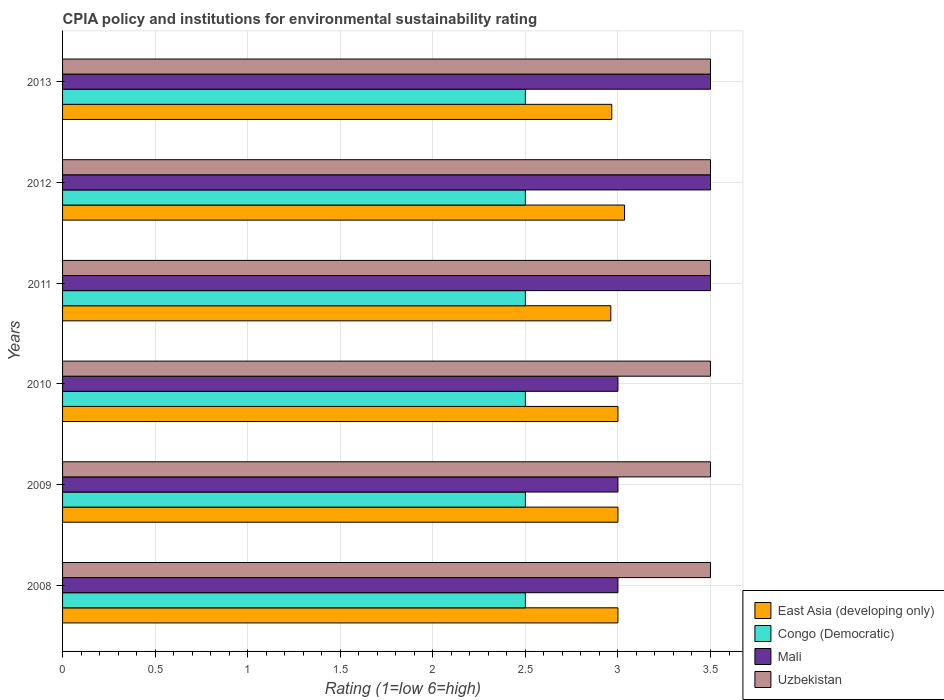How many different coloured bars are there?
Keep it short and to the point. 4. How many groups of bars are there?
Keep it short and to the point. 6. Are the number of bars on each tick of the Y-axis equal?
Keep it short and to the point. Yes. How many bars are there on the 6th tick from the bottom?
Offer a terse response. 4. Across all years, what is the maximum CPIA rating in Mali?
Ensure brevity in your answer.  3.5. In which year was the CPIA rating in East Asia (developing only) maximum?
Offer a very short reply. 2012. What is the average CPIA rating in East Asia (developing only) per year?
Provide a short and direct response. 2.99. In the year 2009, what is the difference between the CPIA rating in Uzbekistan and CPIA rating in East Asia (developing only)?
Offer a terse response. 0.5. In how many years, is the CPIA rating in Mali greater than 0.2 ?
Provide a short and direct response. 6. What is the ratio of the CPIA rating in Mali in 2008 to that in 2009?
Provide a succinct answer. 1. Is the CPIA rating in Mali in 2010 less than that in 2013?
Keep it short and to the point. Yes. Is the difference between the CPIA rating in Uzbekistan in 2012 and 2013 greater than the difference between the CPIA rating in East Asia (developing only) in 2012 and 2013?
Offer a terse response. No. What is the difference between the highest and the second highest CPIA rating in East Asia (developing only)?
Provide a succinct answer. 0.04. What is the difference between the highest and the lowest CPIA rating in Uzbekistan?
Ensure brevity in your answer.  0. In how many years, is the CPIA rating in Congo (Democratic) greater than the average CPIA rating in Congo (Democratic) taken over all years?
Make the answer very short. 0. Is it the case that in every year, the sum of the CPIA rating in East Asia (developing only) and CPIA rating in Uzbekistan is greater than the sum of CPIA rating in Mali and CPIA rating in Congo (Democratic)?
Offer a terse response. Yes. What does the 4th bar from the top in 2008 represents?
Provide a short and direct response. East Asia (developing only). What does the 3rd bar from the bottom in 2012 represents?
Your response must be concise. Mali. Is it the case that in every year, the sum of the CPIA rating in Uzbekistan and CPIA rating in Mali is greater than the CPIA rating in Congo (Democratic)?
Your answer should be very brief. Yes. How many years are there in the graph?
Offer a very short reply. 6. What is the difference between two consecutive major ticks on the X-axis?
Give a very brief answer. 0.5. Are the values on the major ticks of X-axis written in scientific E-notation?
Offer a terse response. No. Does the graph contain any zero values?
Make the answer very short. No. What is the title of the graph?
Ensure brevity in your answer.  CPIA policy and institutions for environmental sustainability rating. Does "Least developed countries" appear as one of the legend labels in the graph?
Make the answer very short. No. What is the label or title of the X-axis?
Offer a terse response. Rating (1=low 6=high). What is the label or title of the Y-axis?
Provide a succinct answer. Years. What is the Rating (1=low 6=high) in East Asia (developing only) in 2008?
Your answer should be very brief. 3. What is the Rating (1=low 6=high) of Congo (Democratic) in 2008?
Make the answer very short. 2.5. What is the Rating (1=low 6=high) of Uzbekistan in 2008?
Offer a very short reply. 3.5. What is the Rating (1=low 6=high) of East Asia (developing only) in 2009?
Provide a succinct answer. 3. What is the Rating (1=low 6=high) in Mali in 2009?
Provide a short and direct response. 3. What is the Rating (1=low 6=high) of Uzbekistan in 2009?
Make the answer very short. 3.5. What is the Rating (1=low 6=high) in Mali in 2010?
Offer a terse response. 3. What is the Rating (1=low 6=high) in East Asia (developing only) in 2011?
Ensure brevity in your answer.  2.96. What is the Rating (1=low 6=high) in East Asia (developing only) in 2012?
Your answer should be very brief. 3.04. What is the Rating (1=low 6=high) in Mali in 2012?
Ensure brevity in your answer.  3.5. What is the Rating (1=low 6=high) in East Asia (developing only) in 2013?
Your response must be concise. 2.97. What is the Rating (1=low 6=high) of Congo (Democratic) in 2013?
Your answer should be very brief. 2.5. What is the Rating (1=low 6=high) of Mali in 2013?
Your answer should be very brief. 3.5. What is the Rating (1=low 6=high) of Uzbekistan in 2013?
Make the answer very short. 3.5. Across all years, what is the maximum Rating (1=low 6=high) of East Asia (developing only)?
Give a very brief answer. 3.04. Across all years, what is the maximum Rating (1=low 6=high) in Congo (Democratic)?
Offer a very short reply. 2.5. Across all years, what is the maximum Rating (1=low 6=high) in Mali?
Provide a short and direct response. 3.5. Across all years, what is the maximum Rating (1=low 6=high) in Uzbekistan?
Keep it short and to the point. 3.5. Across all years, what is the minimum Rating (1=low 6=high) of East Asia (developing only)?
Offer a very short reply. 2.96. Across all years, what is the minimum Rating (1=low 6=high) in Congo (Democratic)?
Make the answer very short. 2.5. Across all years, what is the minimum Rating (1=low 6=high) of Uzbekistan?
Your response must be concise. 3.5. What is the total Rating (1=low 6=high) in East Asia (developing only) in the graph?
Provide a succinct answer. 17.96. What is the total Rating (1=low 6=high) in Congo (Democratic) in the graph?
Provide a succinct answer. 15. What is the total Rating (1=low 6=high) in Mali in the graph?
Offer a terse response. 19.5. What is the total Rating (1=low 6=high) in Uzbekistan in the graph?
Offer a very short reply. 21. What is the difference between the Rating (1=low 6=high) in East Asia (developing only) in 2008 and that in 2010?
Provide a short and direct response. 0. What is the difference between the Rating (1=low 6=high) in East Asia (developing only) in 2008 and that in 2011?
Offer a terse response. 0.04. What is the difference between the Rating (1=low 6=high) in Congo (Democratic) in 2008 and that in 2011?
Provide a short and direct response. 0. What is the difference between the Rating (1=low 6=high) of Mali in 2008 and that in 2011?
Make the answer very short. -0.5. What is the difference between the Rating (1=low 6=high) in East Asia (developing only) in 2008 and that in 2012?
Ensure brevity in your answer.  -0.04. What is the difference between the Rating (1=low 6=high) in Uzbekistan in 2008 and that in 2012?
Your response must be concise. 0. What is the difference between the Rating (1=low 6=high) in East Asia (developing only) in 2008 and that in 2013?
Your answer should be very brief. 0.03. What is the difference between the Rating (1=low 6=high) of Congo (Democratic) in 2008 and that in 2013?
Offer a very short reply. 0. What is the difference between the Rating (1=low 6=high) of Mali in 2008 and that in 2013?
Make the answer very short. -0.5. What is the difference between the Rating (1=low 6=high) in Congo (Democratic) in 2009 and that in 2010?
Keep it short and to the point. 0. What is the difference between the Rating (1=low 6=high) in Mali in 2009 and that in 2010?
Your answer should be compact. 0. What is the difference between the Rating (1=low 6=high) of Uzbekistan in 2009 and that in 2010?
Provide a short and direct response. 0. What is the difference between the Rating (1=low 6=high) in East Asia (developing only) in 2009 and that in 2011?
Your answer should be compact. 0.04. What is the difference between the Rating (1=low 6=high) in Congo (Democratic) in 2009 and that in 2011?
Your answer should be very brief. 0. What is the difference between the Rating (1=low 6=high) of Mali in 2009 and that in 2011?
Ensure brevity in your answer.  -0.5. What is the difference between the Rating (1=low 6=high) of Uzbekistan in 2009 and that in 2011?
Your answer should be very brief. 0. What is the difference between the Rating (1=low 6=high) of East Asia (developing only) in 2009 and that in 2012?
Your answer should be compact. -0.04. What is the difference between the Rating (1=low 6=high) of Congo (Democratic) in 2009 and that in 2012?
Provide a succinct answer. 0. What is the difference between the Rating (1=low 6=high) in Uzbekistan in 2009 and that in 2012?
Give a very brief answer. 0. What is the difference between the Rating (1=low 6=high) of East Asia (developing only) in 2009 and that in 2013?
Make the answer very short. 0.03. What is the difference between the Rating (1=low 6=high) of Congo (Democratic) in 2009 and that in 2013?
Offer a very short reply. 0. What is the difference between the Rating (1=low 6=high) of Uzbekistan in 2009 and that in 2013?
Provide a succinct answer. 0. What is the difference between the Rating (1=low 6=high) of East Asia (developing only) in 2010 and that in 2011?
Give a very brief answer. 0.04. What is the difference between the Rating (1=low 6=high) in Congo (Democratic) in 2010 and that in 2011?
Provide a short and direct response. 0. What is the difference between the Rating (1=low 6=high) in East Asia (developing only) in 2010 and that in 2012?
Your answer should be very brief. -0.04. What is the difference between the Rating (1=low 6=high) of Congo (Democratic) in 2010 and that in 2012?
Keep it short and to the point. 0. What is the difference between the Rating (1=low 6=high) of East Asia (developing only) in 2010 and that in 2013?
Provide a short and direct response. 0.03. What is the difference between the Rating (1=low 6=high) in Uzbekistan in 2010 and that in 2013?
Your answer should be very brief. 0. What is the difference between the Rating (1=low 6=high) of East Asia (developing only) in 2011 and that in 2012?
Make the answer very short. -0.07. What is the difference between the Rating (1=low 6=high) of Mali in 2011 and that in 2012?
Your answer should be very brief. 0. What is the difference between the Rating (1=low 6=high) of Uzbekistan in 2011 and that in 2012?
Your answer should be very brief. 0. What is the difference between the Rating (1=low 6=high) of East Asia (developing only) in 2011 and that in 2013?
Keep it short and to the point. -0.01. What is the difference between the Rating (1=low 6=high) of Congo (Democratic) in 2011 and that in 2013?
Your answer should be compact. 0. What is the difference between the Rating (1=low 6=high) of Mali in 2011 and that in 2013?
Provide a succinct answer. 0. What is the difference between the Rating (1=low 6=high) of Uzbekistan in 2011 and that in 2013?
Ensure brevity in your answer.  0. What is the difference between the Rating (1=low 6=high) in East Asia (developing only) in 2012 and that in 2013?
Provide a short and direct response. 0.07. What is the difference between the Rating (1=low 6=high) of Uzbekistan in 2012 and that in 2013?
Make the answer very short. 0. What is the difference between the Rating (1=low 6=high) in East Asia (developing only) in 2008 and the Rating (1=low 6=high) in Congo (Democratic) in 2009?
Keep it short and to the point. 0.5. What is the difference between the Rating (1=low 6=high) of Congo (Democratic) in 2008 and the Rating (1=low 6=high) of Mali in 2009?
Ensure brevity in your answer.  -0.5. What is the difference between the Rating (1=low 6=high) in Congo (Democratic) in 2008 and the Rating (1=low 6=high) in Uzbekistan in 2009?
Your answer should be very brief. -1. What is the difference between the Rating (1=low 6=high) in Mali in 2008 and the Rating (1=low 6=high) in Uzbekistan in 2009?
Ensure brevity in your answer.  -0.5. What is the difference between the Rating (1=low 6=high) in Congo (Democratic) in 2008 and the Rating (1=low 6=high) in Mali in 2010?
Provide a succinct answer. -0.5. What is the difference between the Rating (1=low 6=high) of Congo (Democratic) in 2008 and the Rating (1=low 6=high) of Uzbekistan in 2010?
Provide a short and direct response. -1. What is the difference between the Rating (1=low 6=high) in Mali in 2008 and the Rating (1=low 6=high) in Uzbekistan in 2010?
Give a very brief answer. -0.5. What is the difference between the Rating (1=low 6=high) in East Asia (developing only) in 2008 and the Rating (1=low 6=high) in Mali in 2011?
Your answer should be compact. -0.5. What is the difference between the Rating (1=low 6=high) of East Asia (developing only) in 2008 and the Rating (1=low 6=high) of Uzbekistan in 2011?
Provide a short and direct response. -0.5. What is the difference between the Rating (1=low 6=high) of Congo (Democratic) in 2008 and the Rating (1=low 6=high) of Mali in 2011?
Keep it short and to the point. -1. What is the difference between the Rating (1=low 6=high) in Mali in 2008 and the Rating (1=low 6=high) in Uzbekistan in 2011?
Your answer should be very brief. -0.5. What is the difference between the Rating (1=low 6=high) of East Asia (developing only) in 2008 and the Rating (1=low 6=high) of Congo (Democratic) in 2012?
Provide a short and direct response. 0.5. What is the difference between the Rating (1=low 6=high) of Congo (Democratic) in 2008 and the Rating (1=low 6=high) of Mali in 2012?
Ensure brevity in your answer.  -1. What is the difference between the Rating (1=low 6=high) of Congo (Democratic) in 2008 and the Rating (1=low 6=high) of Uzbekistan in 2012?
Make the answer very short. -1. What is the difference between the Rating (1=low 6=high) in Mali in 2008 and the Rating (1=low 6=high) in Uzbekistan in 2012?
Offer a terse response. -0.5. What is the difference between the Rating (1=low 6=high) of East Asia (developing only) in 2008 and the Rating (1=low 6=high) of Congo (Democratic) in 2013?
Give a very brief answer. 0.5. What is the difference between the Rating (1=low 6=high) in Congo (Democratic) in 2008 and the Rating (1=low 6=high) in Mali in 2013?
Your answer should be very brief. -1. What is the difference between the Rating (1=low 6=high) in Mali in 2008 and the Rating (1=low 6=high) in Uzbekistan in 2013?
Provide a short and direct response. -0.5. What is the difference between the Rating (1=low 6=high) of East Asia (developing only) in 2009 and the Rating (1=low 6=high) of Uzbekistan in 2010?
Your response must be concise. -0.5. What is the difference between the Rating (1=low 6=high) in Congo (Democratic) in 2009 and the Rating (1=low 6=high) in Mali in 2010?
Your response must be concise. -0.5. What is the difference between the Rating (1=low 6=high) of Congo (Democratic) in 2009 and the Rating (1=low 6=high) of Uzbekistan in 2010?
Ensure brevity in your answer.  -1. What is the difference between the Rating (1=low 6=high) of Mali in 2009 and the Rating (1=low 6=high) of Uzbekistan in 2010?
Make the answer very short. -0.5. What is the difference between the Rating (1=low 6=high) of Congo (Democratic) in 2009 and the Rating (1=low 6=high) of Uzbekistan in 2011?
Your answer should be compact. -1. What is the difference between the Rating (1=low 6=high) in Mali in 2009 and the Rating (1=low 6=high) in Uzbekistan in 2011?
Your response must be concise. -0.5. What is the difference between the Rating (1=low 6=high) in East Asia (developing only) in 2009 and the Rating (1=low 6=high) in Congo (Democratic) in 2012?
Give a very brief answer. 0.5. What is the difference between the Rating (1=low 6=high) in East Asia (developing only) in 2009 and the Rating (1=low 6=high) in Mali in 2012?
Your answer should be compact. -0.5. What is the difference between the Rating (1=low 6=high) in Congo (Democratic) in 2009 and the Rating (1=low 6=high) in Mali in 2012?
Your answer should be very brief. -1. What is the difference between the Rating (1=low 6=high) of East Asia (developing only) in 2009 and the Rating (1=low 6=high) of Congo (Democratic) in 2013?
Keep it short and to the point. 0.5. What is the difference between the Rating (1=low 6=high) in East Asia (developing only) in 2009 and the Rating (1=low 6=high) in Mali in 2013?
Offer a terse response. -0.5. What is the difference between the Rating (1=low 6=high) in East Asia (developing only) in 2010 and the Rating (1=low 6=high) in Congo (Democratic) in 2011?
Offer a terse response. 0.5. What is the difference between the Rating (1=low 6=high) in East Asia (developing only) in 2010 and the Rating (1=low 6=high) in Mali in 2011?
Make the answer very short. -0.5. What is the difference between the Rating (1=low 6=high) of Congo (Democratic) in 2010 and the Rating (1=low 6=high) of Mali in 2011?
Keep it short and to the point. -1. What is the difference between the Rating (1=low 6=high) of Mali in 2010 and the Rating (1=low 6=high) of Uzbekistan in 2011?
Make the answer very short. -0.5. What is the difference between the Rating (1=low 6=high) of East Asia (developing only) in 2010 and the Rating (1=low 6=high) of Congo (Democratic) in 2012?
Provide a short and direct response. 0.5. What is the difference between the Rating (1=low 6=high) of East Asia (developing only) in 2010 and the Rating (1=low 6=high) of Mali in 2012?
Offer a terse response. -0.5. What is the difference between the Rating (1=low 6=high) of East Asia (developing only) in 2010 and the Rating (1=low 6=high) of Uzbekistan in 2012?
Give a very brief answer. -0.5. What is the difference between the Rating (1=low 6=high) of Congo (Democratic) in 2010 and the Rating (1=low 6=high) of Mali in 2012?
Offer a terse response. -1. What is the difference between the Rating (1=low 6=high) in East Asia (developing only) in 2010 and the Rating (1=low 6=high) in Mali in 2013?
Your answer should be very brief. -0.5. What is the difference between the Rating (1=low 6=high) of East Asia (developing only) in 2010 and the Rating (1=low 6=high) of Uzbekistan in 2013?
Offer a terse response. -0.5. What is the difference between the Rating (1=low 6=high) in Congo (Democratic) in 2010 and the Rating (1=low 6=high) in Mali in 2013?
Your response must be concise. -1. What is the difference between the Rating (1=low 6=high) of Mali in 2010 and the Rating (1=low 6=high) of Uzbekistan in 2013?
Ensure brevity in your answer.  -0.5. What is the difference between the Rating (1=low 6=high) in East Asia (developing only) in 2011 and the Rating (1=low 6=high) in Congo (Democratic) in 2012?
Provide a succinct answer. 0.46. What is the difference between the Rating (1=low 6=high) of East Asia (developing only) in 2011 and the Rating (1=low 6=high) of Mali in 2012?
Offer a terse response. -0.54. What is the difference between the Rating (1=low 6=high) in East Asia (developing only) in 2011 and the Rating (1=low 6=high) in Uzbekistan in 2012?
Offer a very short reply. -0.54. What is the difference between the Rating (1=low 6=high) of East Asia (developing only) in 2011 and the Rating (1=low 6=high) of Congo (Democratic) in 2013?
Your response must be concise. 0.46. What is the difference between the Rating (1=low 6=high) in East Asia (developing only) in 2011 and the Rating (1=low 6=high) in Mali in 2013?
Offer a very short reply. -0.54. What is the difference between the Rating (1=low 6=high) in East Asia (developing only) in 2011 and the Rating (1=low 6=high) in Uzbekistan in 2013?
Keep it short and to the point. -0.54. What is the difference between the Rating (1=low 6=high) of Congo (Democratic) in 2011 and the Rating (1=low 6=high) of Mali in 2013?
Your answer should be compact. -1. What is the difference between the Rating (1=low 6=high) in Congo (Democratic) in 2011 and the Rating (1=low 6=high) in Uzbekistan in 2013?
Provide a succinct answer. -1. What is the difference between the Rating (1=low 6=high) of Mali in 2011 and the Rating (1=low 6=high) of Uzbekistan in 2013?
Make the answer very short. 0. What is the difference between the Rating (1=low 6=high) in East Asia (developing only) in 2012 and the Rating (1=low 6=high) in Congo (Democratic) in 2013?
Your response must be concise. 0.54. What is the difference between the Rating (1=low 6=high) of East Asia (developing only) in 2012 and the Rating (1=low 6=high) of Mali in 2013?
Your answer should be compact. -0.46. What is the difference between the Rating (1=low 6=high) in East Asia (developing only) in 2012 and the Rating (1=low 6=high) in Uzbekistan in 2013?
Your answer should be very brief. -0.46. What is the difference between the Rating (1=low 6=high) of Congo (Democratic) in 2012 and the Rating (1=low 6=high) of Mali in 2013?
Your answer should be compact. -1. What is the difference between the Rating (1=low 6=high) of Congo (Democratic) in 2012 and the Rating (1=low 6=high) of Uzbekistan in 2013?
Offer a very short reply. -1. What is the difference between the Rating (1=low 6=high) of Mali in 2012 and the Rating (1=low 6=high) of Uzbekistan in 2013?
Ensure brevity in your answer.  0. What is the average Rating (1=low 6=high) of East Asia (developing only) per year?
Your answer should be very brief. 2.99. What is the average Rating (1=low 6=high) of Congo (Democratic) per year?
Your answer should be very brief. 2.5. What is the average Rating (1=low 6=high) of Mali per year?
Give a very brief answer. 3.25. What is the average Rating (1=low 6=high) in Uzbekistan per year?
Your answer should be very brief. 3.5. In the year 2008, what is the difference between the Rating (1=low 6=high) in East Asia (developing only) and Rating (1=low 6=high) in Congo (Democratic)?
Keep it short and to the point. 0.5. In the year 2008, what is the difference between the Rating (1=low 6=high) of East Asia (developing only) and Rating (1=low 6=high) of Mali?
Provide a short and direct response. 0. In the year 2008, what is the difference between the Rating (1=low 6=high) of Congo (Democratic) and Rating (1=low 6=high) of Mali?
Give a very brief answer. -0.5. In the year 2009, what is the difference between the Rating (1=low 6=high) in East Asia (developing only) and Rating (1=low 6=high) in Uzbekistan?
Your answer should be compact. -0.5. In the year 2009, what is the difference between the Rating (1=low 6=high) of Mali and Rating (1=low 6=high) of Uzbekistan?
Ensure brevity in your answer.  -0.5. In the year 2010, what is the difference between the Rating (1=low 6=high) of Congo (Democratic) and Rating (1=low 6=high) of Mali?
Make the answer very short. -0.5. In the year 2010, what is the difference between the Rating (1=low 6=high) of Congo (Democratic) and Rating (1=low 6=high) of Uzbekistan?
Give a very brief answer. -1. In the year 2011, what is the difference between the Rating (1=low 6=high) of East Asia (developing only) and Rating (1=low 6=high) of Congo (Democratic)?
Your answer should be very brief. 0.46. In the year 2011, what is the difference between the Rating (1=low 6=high) of East Asia (developing only) and Rating (1=low 6=high) of Mali?
Your answer should be very brief. -0.54. In the year 2011, what is the difference between the Rating (1=low 6=high) in East Asia (developing only) and Rating (1=low 6=high) in Uzbekistan?
Your response must be concise. -0.54. In the year 2011, what is the difference between the Rating (1=low 6=high) of Congo (Democratic) and Rating (1=low 6=high) of Mali?
Your response must be concise. -1. In the year 2011, what is the difference between the Rating (1=low 6=high) of Congo (Democratic) and Rating (1=low 6=high) of Uzbekistan?
Provide a succinct answer. -1. In the year 2012, what is the difference between the Rating (1=low 6=high) of East Asia (developing only) and Rating (1=low 6=high) of Congo (Democratic)?
Offer a very short reply. 0.54. In the year 2012, what is the difference between the Rating (1=low 6=high) in East Asia (developing only) and Rating (1=low 6=high) in Mali?
Your response must be concise. -0.46. In the year 2012, what is the difference between the Rating (1=low 6=high) of East Asia (developing only) and Rating (1=low 6=high) of Uzbekistan?
Provide a short and direct response. -0.46. In the year 2012, what is the difference between the Rating (1=low 6=high) in Congo (Democratic) and Rating (1=low 6=high) in Mali?
Give a very brief answer. -1. In the year 2012, what is the difference between the Rating (1=low 6=high) of Congo (Democratic) and Rating (1=low 6=high) of Uzbekistan?
Provide a succinct answer. -1. In the year 2012, what is the difference between the Rating (1=low 6=high) of Mali and Rating (1=low 6=high) of Uzbekistan?
Your response must be concise. 0. In the year 2013, what is the difference between the Rating (1=low 6=high) of East Asia (developing only) and Rating (1=low 6=high) of Congo (Democratic)?
Your answer should be compact. 0.47. In the year 2013, what is the difference between the Rating (1=low 6=high) in East Asia (developing only) and Rating (1=low 6=high) in Mali?
Provide a short and direct response. -0.53. In the year 2013, what is the difference between the Rating (1=low 6=high) of East Asia (developing only) and Rating (1=low 6=high) of Uzbekistan?
Give a very brief answer. -0.53. In the year 2013, what is the difference between the Rating (1=low 6=high) of Congo (Democratic) and Rating (1=low 6=high) of Mali?
Your response must be concise. -1. In the year 2013, what is the difference between the Rating (1=low 6=high) of Congo (Democratic) and Rating (1=low 6=high) of Uzbekistan?
Ensure brevity in your answer.  -1. In the year 2013, what is the difference between the Rating (1=low 6=high) in Mali and Rating (1=low 6=high) in Uzbekistan?
Provide a short and direct response. 0. What is the ratio of the Rating (1=low 6=high) of Mali in 2008 to that in 2009?
Your answer should be compact. 1. What is the ratio of the Rating (1=low 6=high) of Uzbekistan in 2008 to that in 2009?
Ensure brevity in your answer.  1. What is the ratio of the Rating (1=low 6=high) of East Asia (developing only) in 2008 to that in 2010?
Your answer should be compact. 1. What is the ratio of the Rating (1=low 6=high) in Uzbekistan in 2008 to that in 2010?
Offer a terse response. 1. What is the ratio of the Rating (1=low 6=high) in East Asia (developing only) in 2008 to that in 2011?
Give a very brief answer. 1.01. What is the ratio of the Rating (1=low 6=high) in Congo (Democratic) in 2008 to that in 2011?
Keep it short and to the point. 1. What is the ratio of the Rating (1=low 6=high) of Uzbekistan in 2008 to that in 2011?
Ensure brevity in your answer.  1. What is the ratio of the Rating (1=low 6=high) in Congo (Democratic) in 2008 to that in 2012?
Give a very brief answer. 1. What is the ratio of the Rating (1=low 6=high) in Mali in 2008 to that in 2012?
Provide a succinct answer. 0.86. What is the ratio of the Rating (1=low 6=high) of Uzbekistan in 2008 to that in 2012?
Ensure brevity in your answer.  1. What is the ratio of the Rating (1=low 6=high) of East Asia (developing only) in 2008 to that in 2013?
Give a very brief answer. 1.01. What is the ratio of the Rating (1=low 6=high) in Mali in 2008 to that in 2013?
Provide a succinct answer. 0.86. What is the ratio of the Rating (1=low 6=high) in East Asia (developing only) in 2009 to that in 2010?
Your answer should be compact. 1. What is the ratio of the Rating (1=low 6=high) in East Asia (developing only) in 2009 to that in 2011?
Your response must be concise. 1.01. What is the ratio of the Rating (1=low 6=high) of East Asia (developing only) in 2009 to that in 2012?
Provide a succinct answer. 0.99. What is the ratio of the Rating (1=low 6=high) in Mali in 2009 to that in 2012?
Your response must be concise. 0.86. What is the ratio of the Rating (1=low 6=high) in Uzbekistan in 2009 to that in 2012?
Provide a short and direct response. 1. What is the ratio of the Rating (1=low 6=high) of East Asia (developing only) in 2009 to that in 2013?
Provide a short and direct response. 1.01. What is the ratio of the Rating (1=low 6=high) of Congo (Democratic) in 2009 to that in 2013?
Your answer should be very brief. 1. What is the ratio of the Rating (1=low 6=high) in Mali in 2009 to that in 2013?
Your answer should be very brief. 0.86. What is the ratio of the Rating (1=low 6=high) in Uzbekistan in 2009 to that in 2013?
Your answer should be compact. 1. What is the ratio of the Rating (1=low 6=high) of East Asia (developing only) in 2010 to that in 2011?
Keep it short and to the point. 1.01. What is the ratio of the Rating (1=low 6=high) of Uzbekistan in 2010 to that in 2011?
Your answer should be very brief. 1. What is the ratio of the Rating (1=low 6=high) of East Asia (developing only) in 2010 to that in 2012?
Keep it short and to the point. 0.99. What is the ratio of the Rating (1=low 6=high) of Mali in 2010 to that in 2012?
Make the answer very short. 0.86. What is the ratio of the Rating (1=low 6=high) in East Asia (developing only) in 2010 to that in 2013?
Give a very brief answer. 1.01. What is the ratio of the Rating (1=low 6=high) in Mali in 2010 to that in 2013?
Ensure brevity in your answer.  0.86. What is the ratio of the Rating (1=low 6=high) of Uzbekistan in 2010 to that in 2013?
Ensure brevity in your answer.  1. What is the ratio of the Rating (1=low 6=high) of East Asia (developing only) in 2011 to that in 2012?
Offer a very short reply. 0.98. What is the ratio of the Rating (1=low 6=high) in Mali in 2011 to that in 2012?
Give a very brief answer. 1. What is the ratio of the Rating (1=low 6=high) of Congo (Democratic) in 2011 to that in 2013?
Provide a short and direct response. 1. What is the ratio of the Rating (1=low 6=high) in Uzbekistan in 2011 to that in 2013?
Your response must be concise. 1. What is the ratio of the Rating (1=low 6=high) of East Asia (developing only) in 2012 to that in 2013?
Your answer should be compact. 1.02. What is the ratio of the Rating (1=low 6=high) of Congo (Democratic) in 2012 to that in 2013?
Give a very brief answer. 1. What is the ratio of the Rating (1=low 6=high) of Uzbekistan in 2012 to that in 2013?
Offer a terse response. 1. What is the difference between the highest and the second highest Rating (1=low 6=high) of East Asia (developing only)?
Your answer should be compact. 0.04. What is the difference between the highest and the second highest Rating (1=low 6=high) of Uzbekistan?
Provide a short and direct response. 0. What is the difference between the highest and the lowest Rating (1=low 6=high) of East Asia (developing only)?
Offer a very short reply. 0.07. What is the difference between the highest and the lowest Rating (1=low 6=high) of Uzbekistan?
Make the answer very short. 0. 